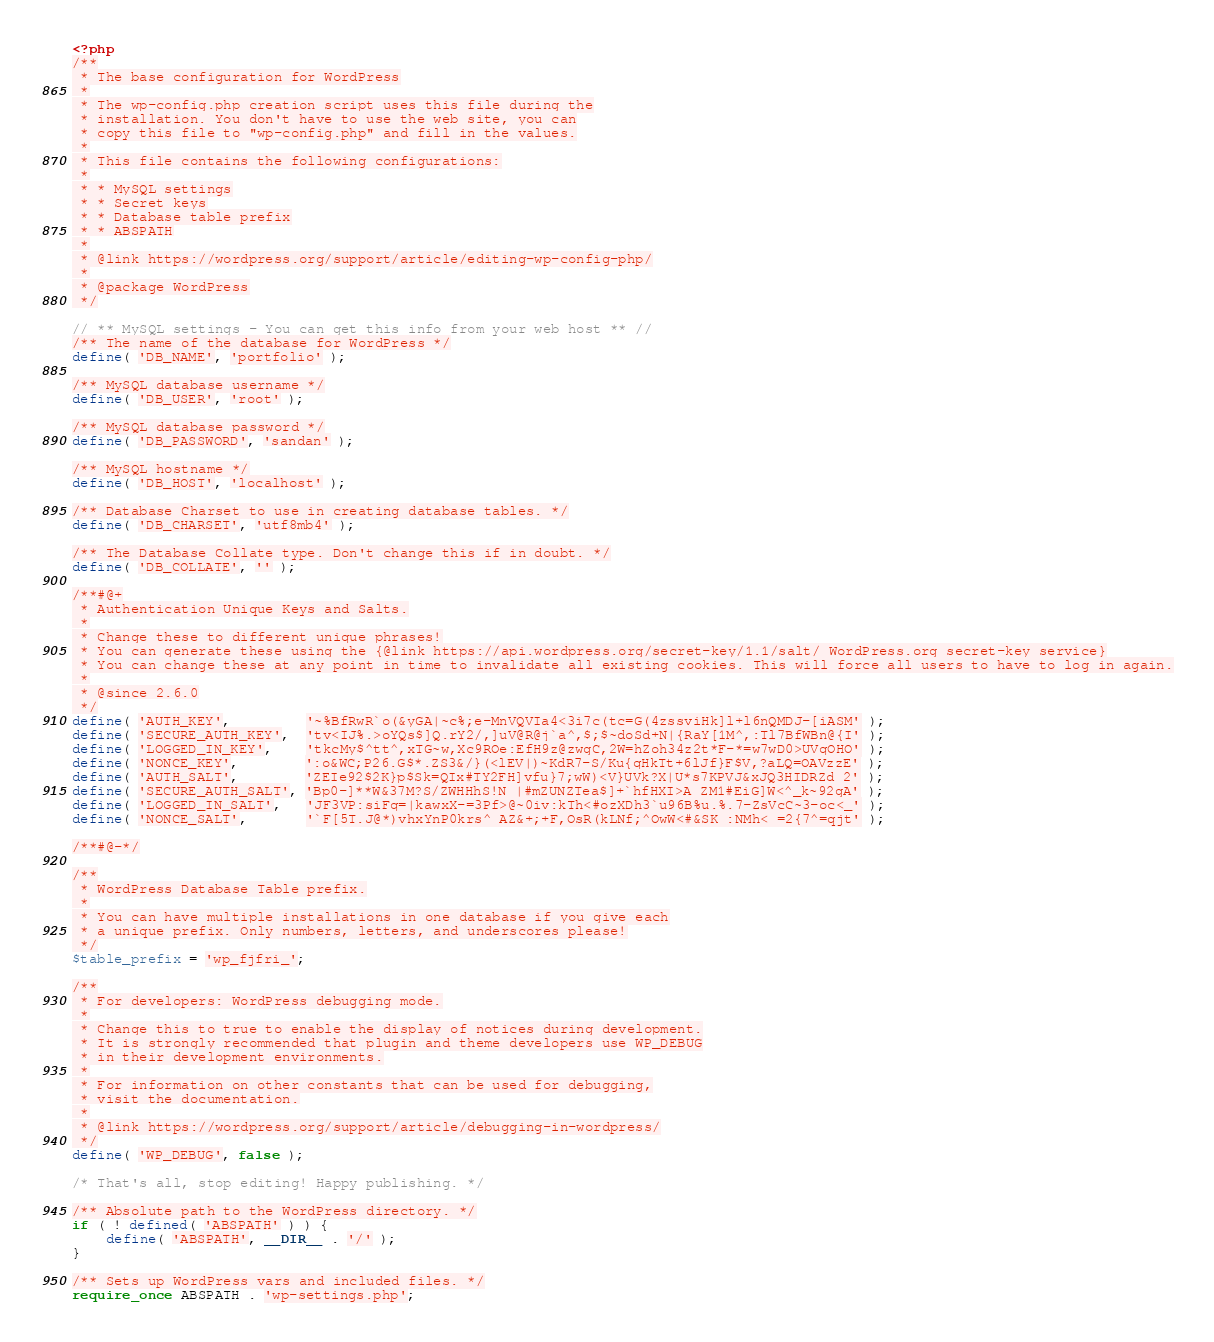Convert code to text. <code><loc_0><loc_0><loc_500><loc_500><_PHP_><?php
/**
 * The base configuration for WordPress
 *
 * The wp-config.php creation script uses this file during the
 * installation. You don't have to use the web site, you can
 * copy this file to "wp-config.php" and fill in the values.
 *
 * This file contains the following configurations:
 *
 * * MySQL settings
 * * Secret keys
 * * Database table prefix
 * * ABSPATH
 *
 * @link https://wordpress.org/support/article/editing-wp-config-php/
 *
 * @package WordPress
 */

// ** MySQL settings - You can get this info from your web host ** //
/** The name of the database for WordPress */
define( 'DB_NAME', 'portfolio' );

/** MySQL database username */
define( 'DB_USER', 'root' );

/** MySQL database password */
define( 'DB_PASSWORD', 'sandan' );

/** MySQL hostname */
define( 'DB_HOST', 'localhost' );

/** Database Charset to use in creating database tables. */
define( 'DB_CHARSET', 'utf8mb4' );

/** The Database Collate type. Don't change this if in doubt. */
define( 'DB_COLLATE', '' );

/**#@+
 * Authentication Unique Keys and Salts.
 *
 * Change these to different unique phrases!
 * You can generate these using the {@link https://api.wordpress.org/secret-key/1.1/salt/ WordPress.org secret-key service}
 * You can change these at any point in time to invalidate all existing cookies. This will force all users to have to log in again.
 *
 * @since 2.6.0
 */
define( 'AUTH_KEY',         '~%BfRwR`o(&yGA|~c%;e-MnVQVIa4<3i7c(tc=G(4zssviHk]l+l6nQMDJ-[iASM' );
define( 'SECURE_AUTH_KEY',  'tv<IJ%.>oYQs$]Q.rY2/,]uV@R@j`a^,$;$~doSd+N|{RaY[1M^,:Tl7BfWBn@{I' );
define( 'LOGGED_IN_KEY',    'tkcMy$^tt^,xTG~w,Xc9ROe:EfH9z@zwgC,2W=hZoh34z2t*F-*=w7wD0>UVqOHO' );
define( 'NONCE_KEY',        ':o&WC;P26.G$*.ZS3&/}(<lEV|)~KdR7-S/Ku{qHkTt+6lJf}F$V,?aLQ=OAVzzE' );
define( 'AUTH_SALT',        'ZEIe92$2K}p$Sk=QIx#TY2FH]vfu}7;wW)<V}UVk?X|U*s7KPVJ&xJQ3HIDRZd 2' );
define( 'SECURE_AUTH_SALT', 'Bp0-]**W&37M?S/ZWHHhS!N |#mZUNZTea$]+`hfHXI>A ZM1#EiG]W<^_k~92gA' );
define( 'LOGGED_IN_SALT',   'JF3VP:siFq=|kawxX-=3Pf>@~0iv:kTh<#ozXDh3`u96B%u.%.7-ZsVcC~3-oc<_' );
define( 'NONCE_SALT',       '`F[5T.J@*)vhxYnP0krs^ AZ&+;+F,OsR(kLNf;^OwW<#&SK :NMh< =2{7^=qjt' );

/**#@-*/

/**
 * WordPress Database Table prefix.
 *
 * You can have multiple installations in one database if you give each
 * a unique prefix. Only numbers, letters, and underscores please!
 */
$table_prefix = 'wp_fjfri_';

/**
 * For developers: WordPress debugging mode.
 *
 * Change this to true to enable the display of notices during development.
 * It is strongly recommended that plugin and theme developers use WP_DEBUG
 * in their development environments.
 *
 * For information on other constants that can be used for debugging,
 * visit the documentation.
 *
 * @link https://wordpress.org/support/article/debugging-in-wordpress/
 */
define( 'WP_DEBUG', false );

/* That's all, stop editing! Happy publishing. */

/** Absolute path to the WordPress directory. */
if ( ! defined( 'ABSPATH' ) ) {
	define( 'ABSPATH', __DIR__ . '/' );
}

/** Sets up WordPress vars and included files. */
require_once ABSPATH . 'wp-settings.php';
</code> 